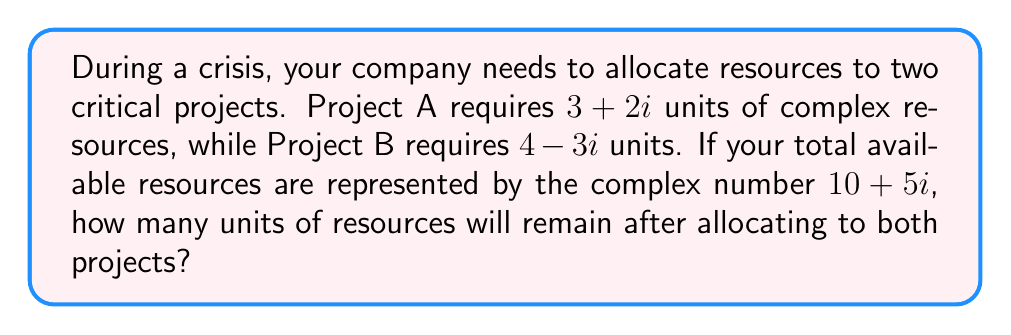Give your solution to this math problem. To solve this problem, we'll follow these steps:

1) First, let's define our variables:
   - Total resources: $10+5i$
   - Project A requirements: $3+2i$
   - Project B requirements: $4-3i$

2) To find the remaining resources, we need to subtract the resources allocated to both projects from the total resources:

   Remaining resources = Total resources - (Project A + Project B)

3) Let's add the resources for Project A and Project B:
   $(3+2i) + (4-3i) = 7-i$

4) Now, we can subtract this from the total resources:
   $(10+5i) - (7-i) = (10+5i) - 7 + i$

5) Simplifying:
   $10+5i-7+i = 3+6i$

6) Therefore, the remaining resources are represented by the complex number $3+6i$.

7) To find the number of units, we calculate the magnitude of this complex number:
   $|3+6i| = \sqrt{3^2 + 6^2} = \sqrt{9 + 36} = \sqrt{45} = 3\sqrt{5}$
Answer: $3\sqrt{5}$ units 